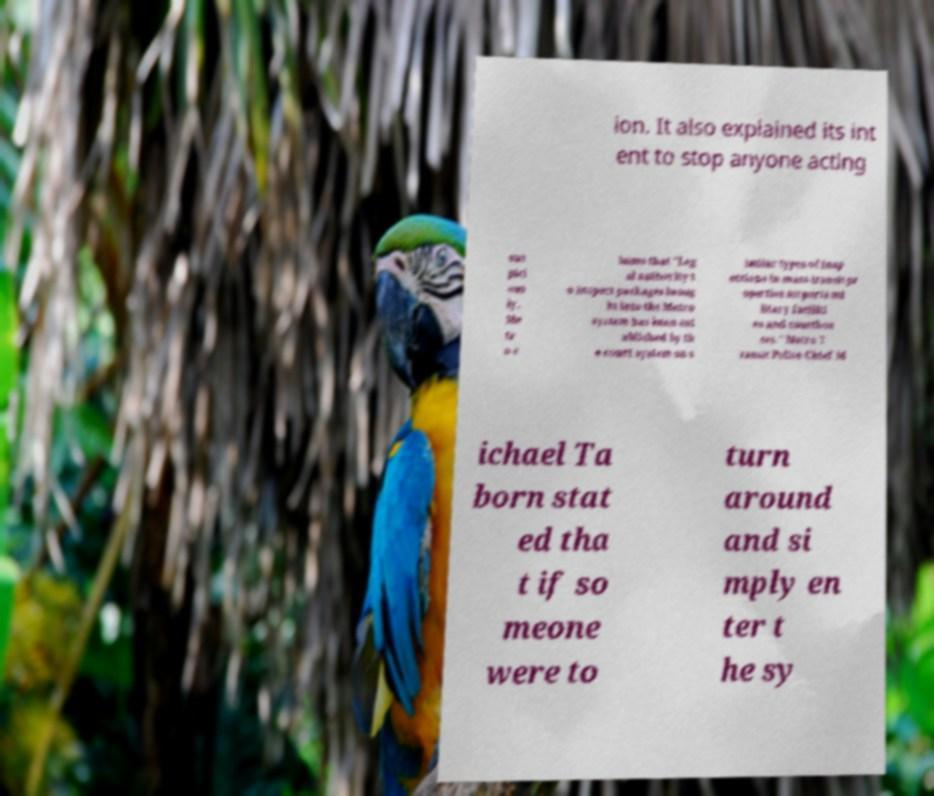There's text embedded in this image that I need extracted. Can you transcribe it verbatim? ion. It also explained its int ent to stop anyone acting sus pici ous ly. Me tr o c laims that "Leg al authority t o inspect packages broug ht into the Metro system has been est ablished by th e court system on s imilar types of insp ections in mass transit pr operties airports mi litary faciliti es and courthou ses." Metro T ransit Police Chief M ichael Ta born stat ed tha t if so meone were to turn around and si mply en ter t he sy 